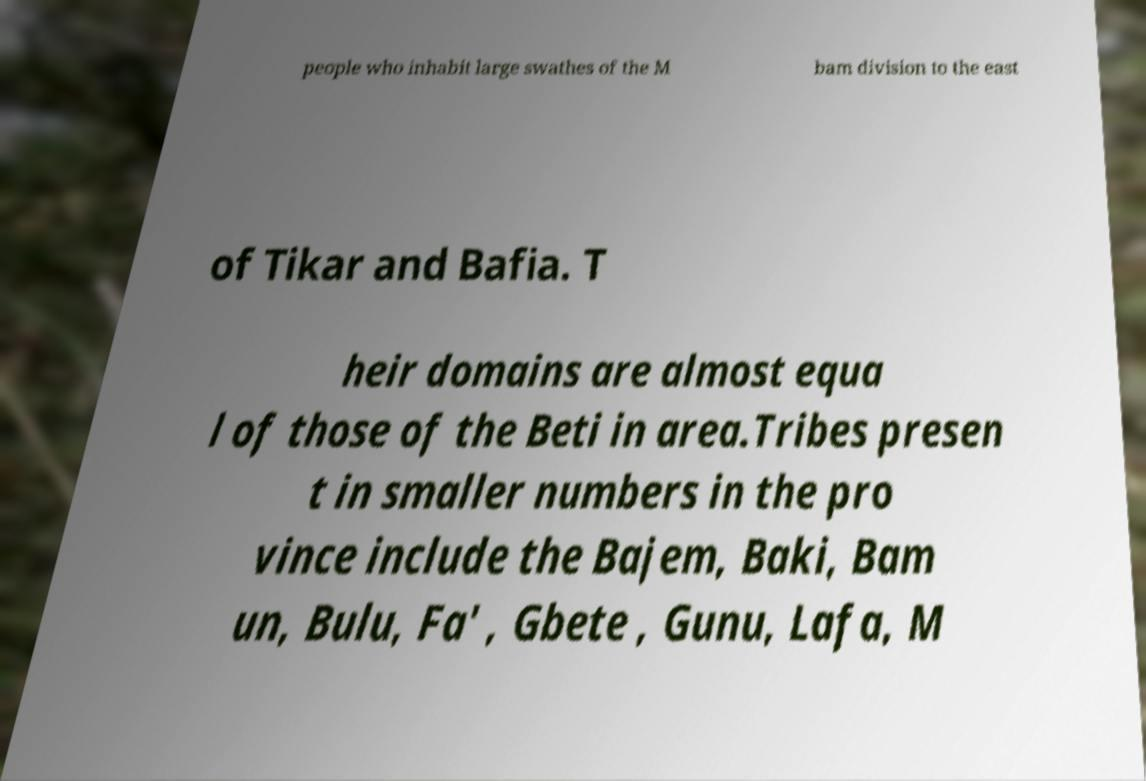There's text embedded in this image that I need extracted. Can you transcribe it verbatim? people who inhabit large swathes of the M bam division to the east of Tikar and Bafia. T heir domains are almost equa l of those of the Beti in area.Tribes presen t in smaller numbers in the pro vince include the Bajem, Baki, Bam un, Bulu, Fa' , Gbete , Gunu, Lafa, M 